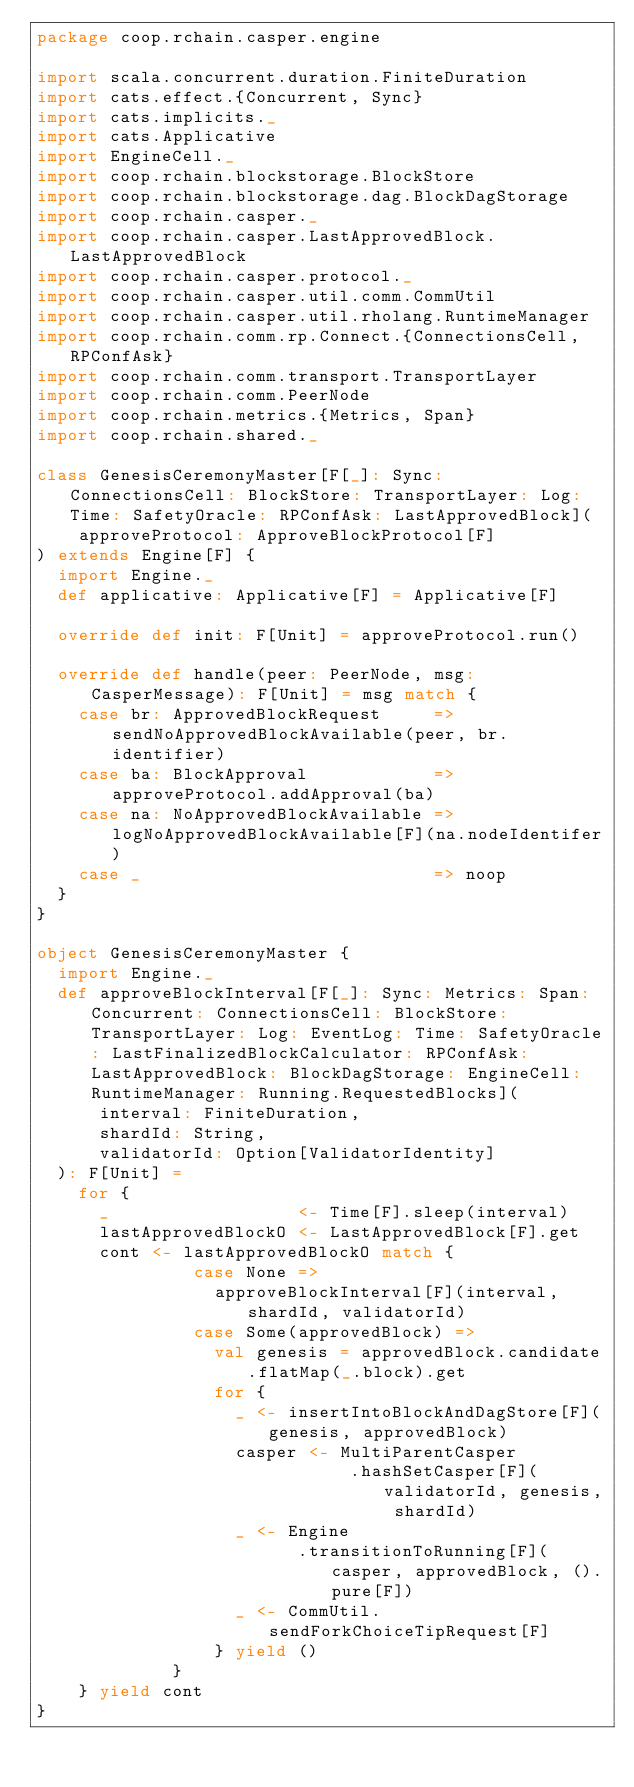Convert code to text. <code><loc_0><loc_0><loc_500><loc_500><_Scala_>package coop.rchain.casper.engine

import scala.concurrent.duration.FiniteDuration
import cats.effect.{Concurrent, Sync}
import cats.implicits._
import cats.Applicative
import EngineCell._
import coop.rchain.blockstorage.BlockStore
import coop.rchain.blockstorage.dag.BlockDagStorage
import coop.rchain.casper._
import coop.rchain.casper.LastApprovedBlock.LastApprovedBlock
import coop.rchain.casper.protocol._
import coop.rchain.casper.util.comm.CommUtil
import coop.rchain.casper.util.rholang.RuntimeManager
import coop.rchain.comm.rp.Connect.{ConnectionsCell, RPConfAsk}
import coop.rchain.comm.transport.TransportLayer
import coop.rchain.comm.PeerNode
import coop.rchain.metrics.{Metrics, Span}
import coop.rchain.shared._

class GenesisCeremonyMaster[F[_]: Sync: ConnectionsCell: BlockStore: TransportLayer: Log: Time: SafetyOracle: RPConfAsk: LastApprovedBlock](
    approveProtocol: ApproveBlockProtocol[F]
) extends Engine[F] {
  import Engine._
  def applicative: Applicative[F] = Applicative[F]

  override def init: F[Unit] = approveProtocol.run()

  override def handle(peer: PeerNode, msg: CasperMessage): F[Unit] = msg match {
    case br: ApprovedBlockRequest     => sendNoApprovedBlockAvailable(peer, br.identifier)
    case ba: BlockApproval            => approveProtocol.addApproval(ba)
    case na: NoApprovedBlockAvailable => logNoApprovedBlockAvailable[F](na.nodeIdentifer)
    case _                            => noop
  }
}

object GenesisCeremonyMaster {
  import Engine._
  def approveBlockInterval[F[_]: Sync: Metrics: Span: Concurrent: ConnectionsCell: BlockStore: TransportLayer: Log: EventLog: Time: SafetyOracle: LastFinalizedBlockCalculator: RPConfAsk: LastApprovedBlock: BlockDagStorage: EngineCell: RuntimeManager: Running.RequestedBlocks](
      interval: FiniteDuration,
      shardId: String,
      validatorId: Option[ValidatorIdentity]
  ): F[Unit] =
    for {
      _                  <- Time[F].sleep(interval)
      lastApprovedBlockO <- LastApprovedBlock[F].get
      cont <- lastApprovedBlockO match {
               case None =>
                 approveBlockInterval[F](interval, shardId, validatorId)
               case Some(approvedBlock) =>
                 val genesis = approvedBlock.candidate.flatMap(_.block).get
                 for {
                   _ <- insertIntoBlockAndDagStore[F](genesis, approvedBlock)
                   casper <- MultiParentCasper
                              .hashSetCasper[F](validatorId, genesis, shardId)
                   _ <- Engine
                         .transitionToRunning[F](casper, approvedBlock, ().pure[F])
                   _ <- CommUtil.sendForkChoiceTipRequest[F]
                 } yield ()
             }
    } yield cont
}
</code> 